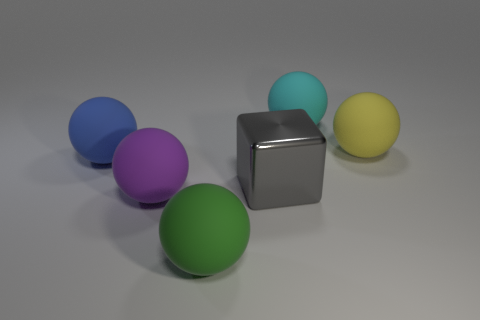How does the lighting in the scene affect the appearance of the objects? The lighting in the scene is diffuse, casting soft shadows and giving the objects a matte appearance. This lack of harsh highlights helps to bring out the true colors of the objects without overexposing any parts. The even distribution of light ensures that each object is distinctly visible and the colors are well represented. Does the surface of the objects reflect the light in any particular way that is noticeable? Yes, the objects have different finishes, which affects how they reflect light. The cube, for example, has a reflective, almost metallic surface that shows some light glare and subtle reflections. The spheres appear to have a less reflective, rubber-like texture which diffuses the light more, hence why their shadows are softer, and the glare is minimal. 